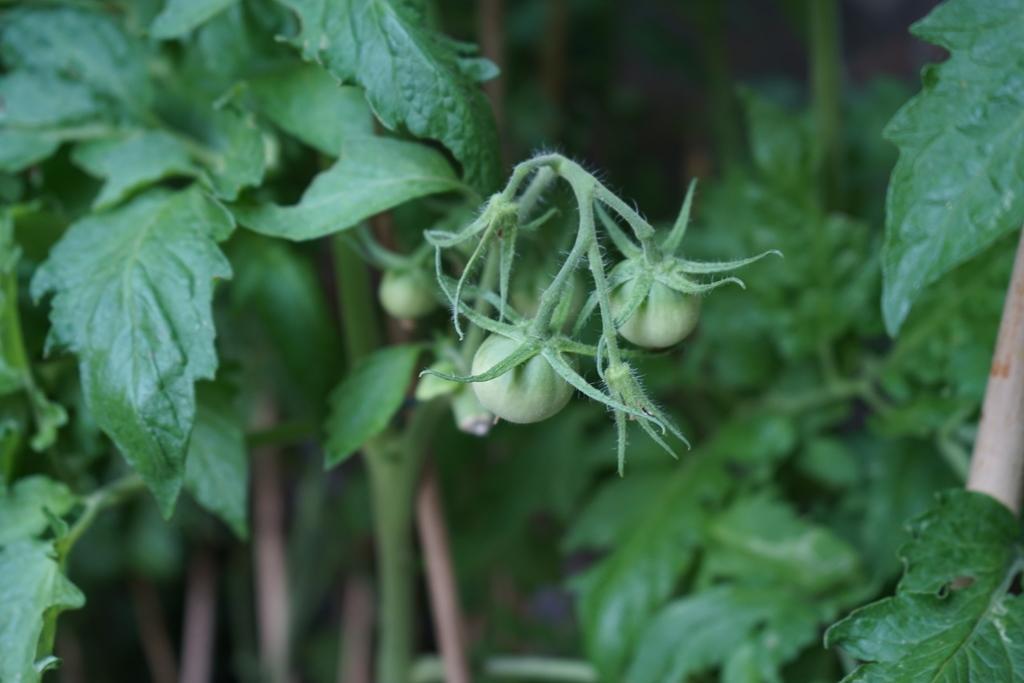Please provide a concise description of this image. In the image we can see raw tomatoes, stem and leaves. 